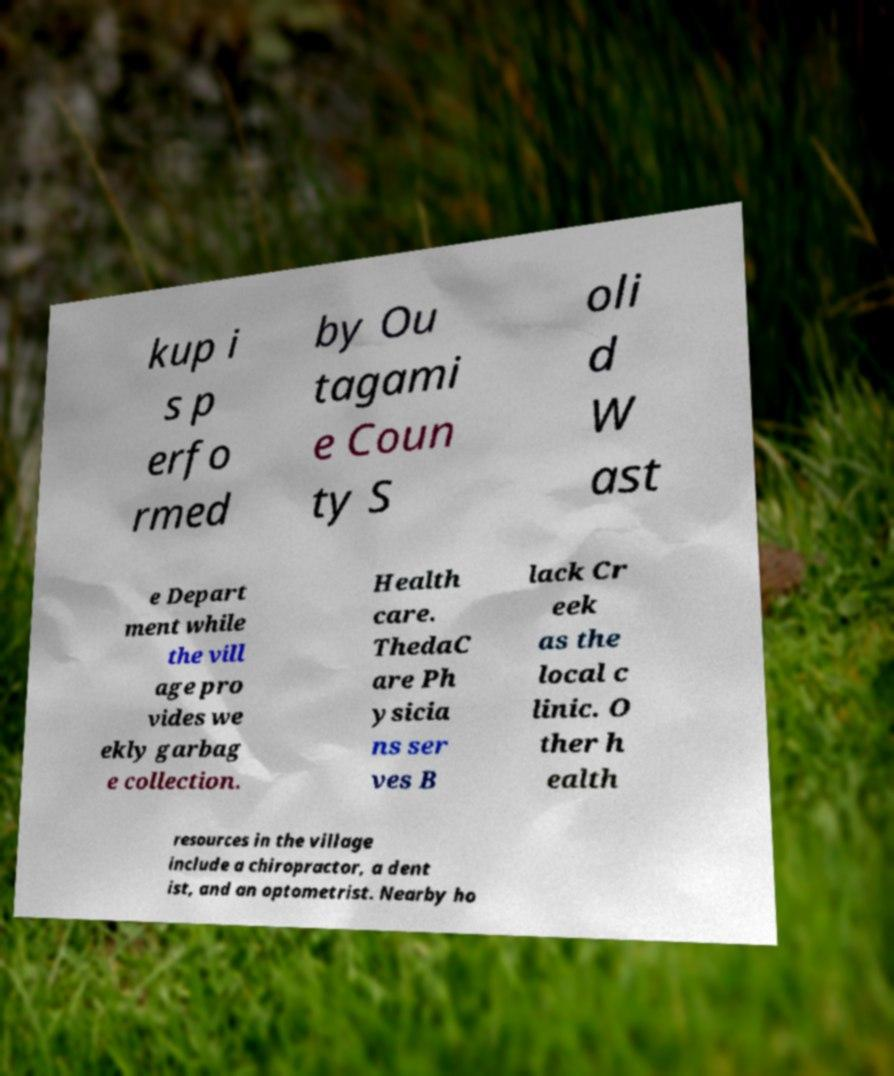Please identify and transcribe the text found in this image. kup i s p erfo rmed by Ou tagami e Coun ty S oli d W ast e Depart ment while the vill age pro vides we ekly garbag e collection. Health care. ThedaC are Ph ysicia ns ser ves B lack Cr eek as the local c linic. O ther h ealth resources in the village include a chiropractor, a dent ist, and an optometrist. Nearby ho 